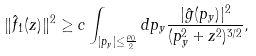<formula> <loc_0><loc_0><loc_500><loc_500>\| \hat { f } _ { 1 } ( z ) \| ^ { 2 } \geq c \int _ { | p _ { y } | \leq \frac { \rho _ { 0 } } 2 } d p _ { y } \frac { | \hat { g } ( p _ { y } ) | ^ { 2 } } { ( p _ { y } ^ { 2 } + z ^ { 2 } ) ^ { 3 / 2 } } ,</formula> 